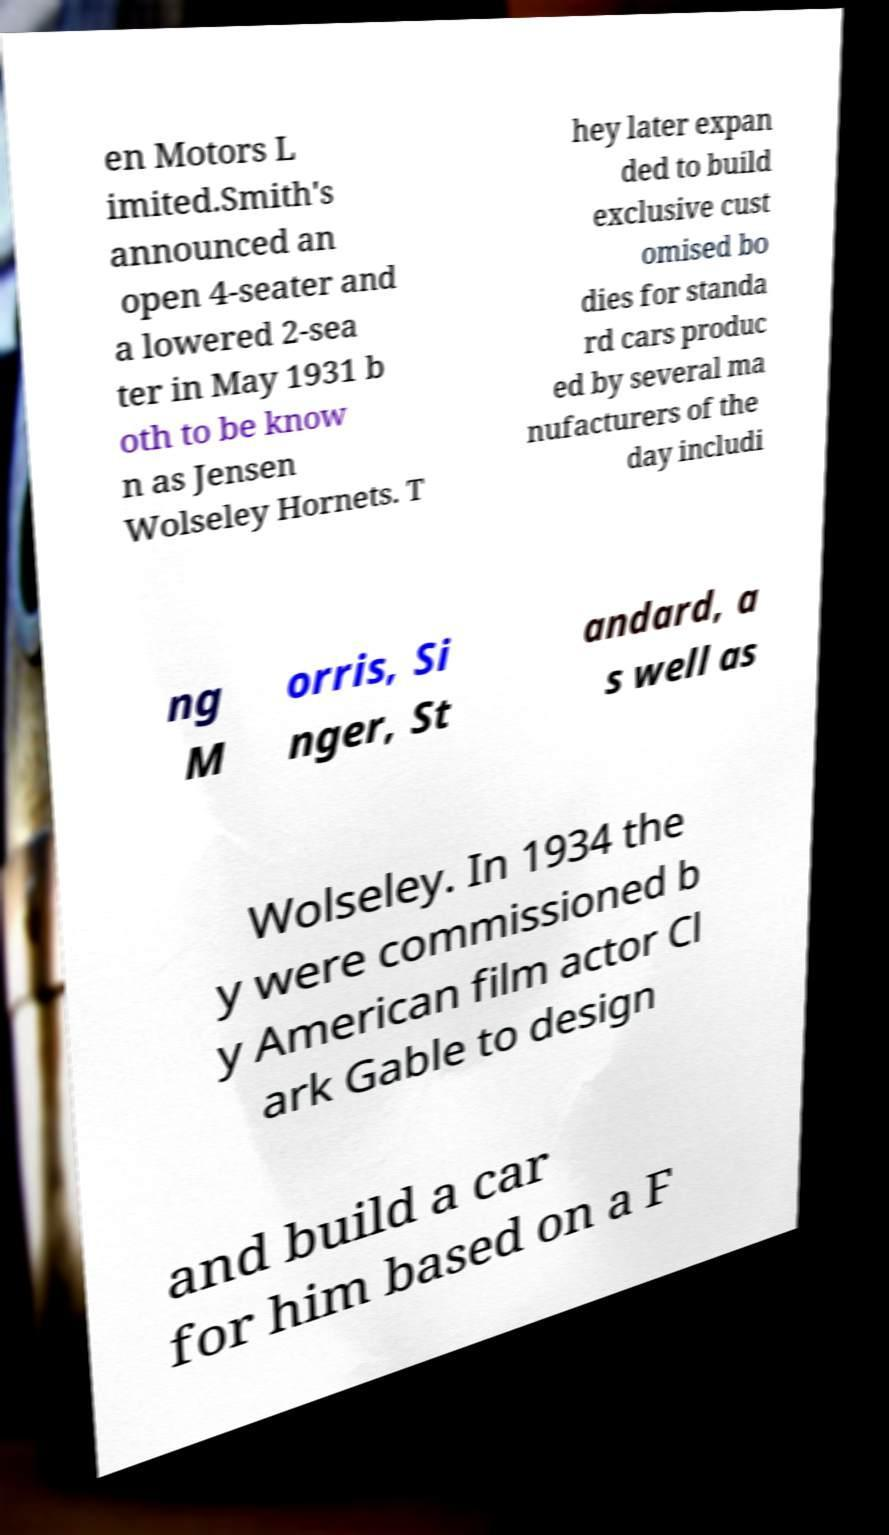What messages or text are displayed in this image? I need them in a readable, typed format. en Motors L imited.Smith's announced an open 4-seater and a lowered 2-sea ter in May 1931 b oth to be know n as Jensen Wolseley Hornets. T hey later expan ded to build exclusive cust omised bo dies for standa rd cars produc ed by several ma nufacturers of the day includi ng M orris, Si nger, St andard, a s well as Wolseley. In 1934 the y were commissioned b y American film actor Cl ark Gable to design and build a car for him based on a F 